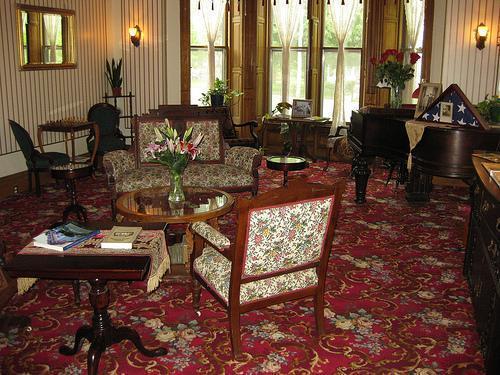How many windows are there?
Give a very brief answer. 4. How many flower vases are there?
Give a very brief answer. 2. How many books are on the table in the foreground?
Give a very brief answer. 2. 